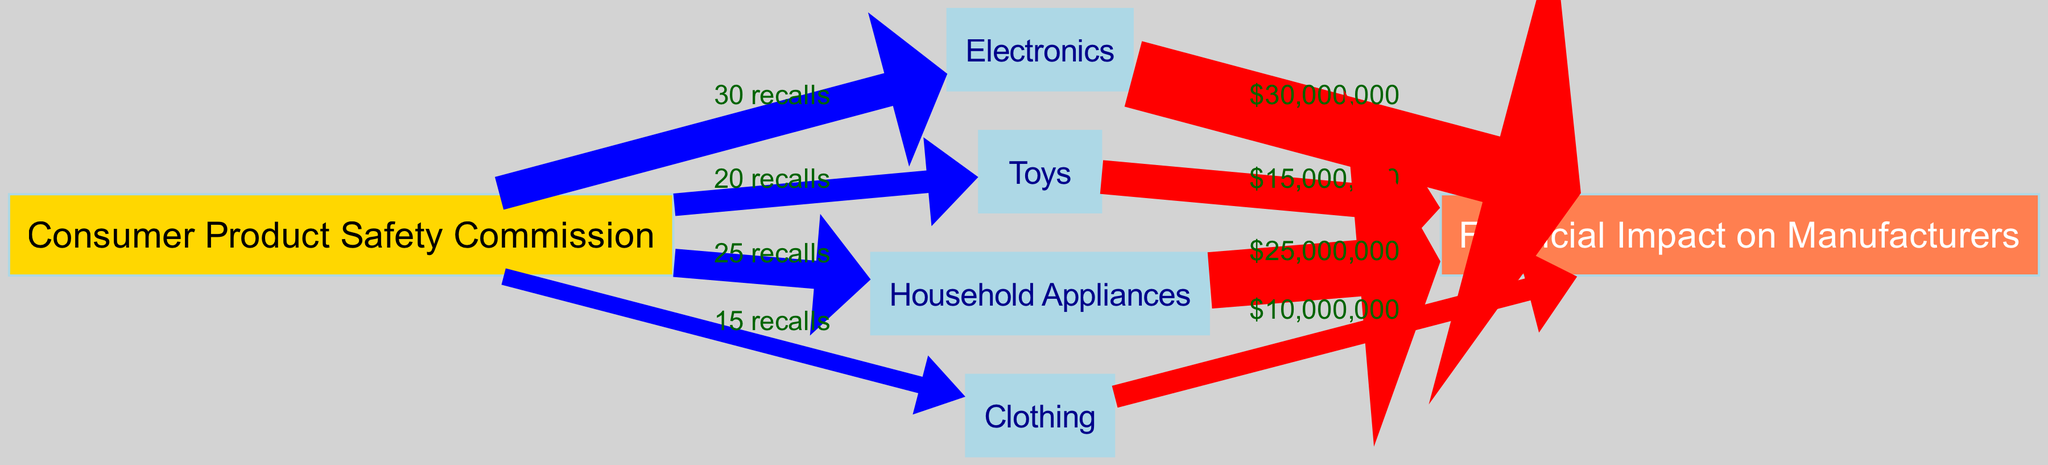What is the total number of product categories represented in the diagram? The diagram contains four product categories: Electronics, Toys, Household Appliances, and Clothing. Counting these, we determine that there are four distinct categories displayed.
Answer: 4 Which product category has the highest number of recalls? By examining the links, we see that Electronics has 30 recalls, which is greater than the number of recalls for the other categories (20 for Toys, 25 for Household Appliances, and 15 for Clothing). This indicates that Electronics has the highest number of recalls.
Answer: Electronics What is the financial impact of Toy recalls on manufacturers? The diagram shows a link from Toys to Financial Impact with a value of $15,000,000. This represents the financial implication associated with Toy recalls, indicating a direct monetary consequence for manufacturers.
Answer: $15,000,000 Which category generates the most financial impact on manufacturers? Analyzing the financial impacts listed, Electronics has a total financial impact value of $30,000,000, which is greater than the other categories (Toys at $15,000,000, Household Appliances at $25,000,000, and Clothing at $10,000,000). Therefore, Electronics generates the most financial impact on manufacturers.
Answer: Electronics How many recalls are associated with Clothing? From the diagram, we observe that Clothing has a total of 15 recalls indicated by the link from the Consumer Product Safety Commission to Clothing. This clearly translates to the number of recalls associated with that specific category.
Answer: 15 What is the total financial impact from Household Appliance recalls? The diagram details a financial impact of $25,000,000 flowing from Household Appliances to the Financial Impact node. Thus, the total financial impact stemming from recalls in this category amounts to the specified value.
Answer: $25,000,000 Which category has the least financial impact on manufacturers? Evaluating the financial impacts, Clothing has the lowest value at $10,000,000 compared to the others (Electronics at $30,000,000, Toys at $15,000,000, and Household Appliances at $25,000,000). This makes Clothing the category with the least financial impact.
Answer: Clothing What is the relationship between Electronics and Financial Impact? The diagram illustrates a direct link from Electronics to Financial Impact, denoted by a value of $30,000,000. This relationship indicates the monetary consequence of recalls in the Electronics category for manufacturers.
Answer: Direct link with $30,000,000 What do the colored edges between nodes represent? The colored edges indicate the nature of the relationships: blue edges represent the number of recalls while red edges signify the financial impacts on manufacturers. This color-coding helps differentiate between recall data and financial consequences.
Answer: Recalls and financial impacts 